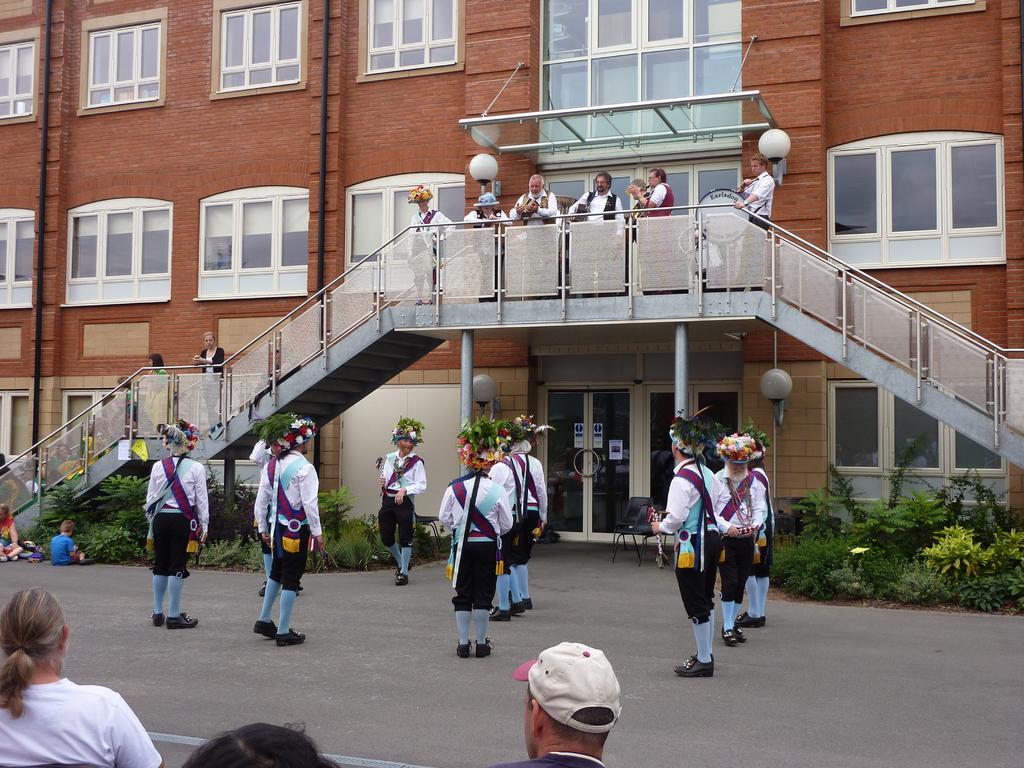How would you summarize this image in a sentence or two? There are few people wearing white and black uniform. They are holding something in the hand. On the head there is a cap with flowers and leaves. Also there are many other people. In the back there is a building with windows, doors and steps with railings. Also there are many people standing on the steps. 